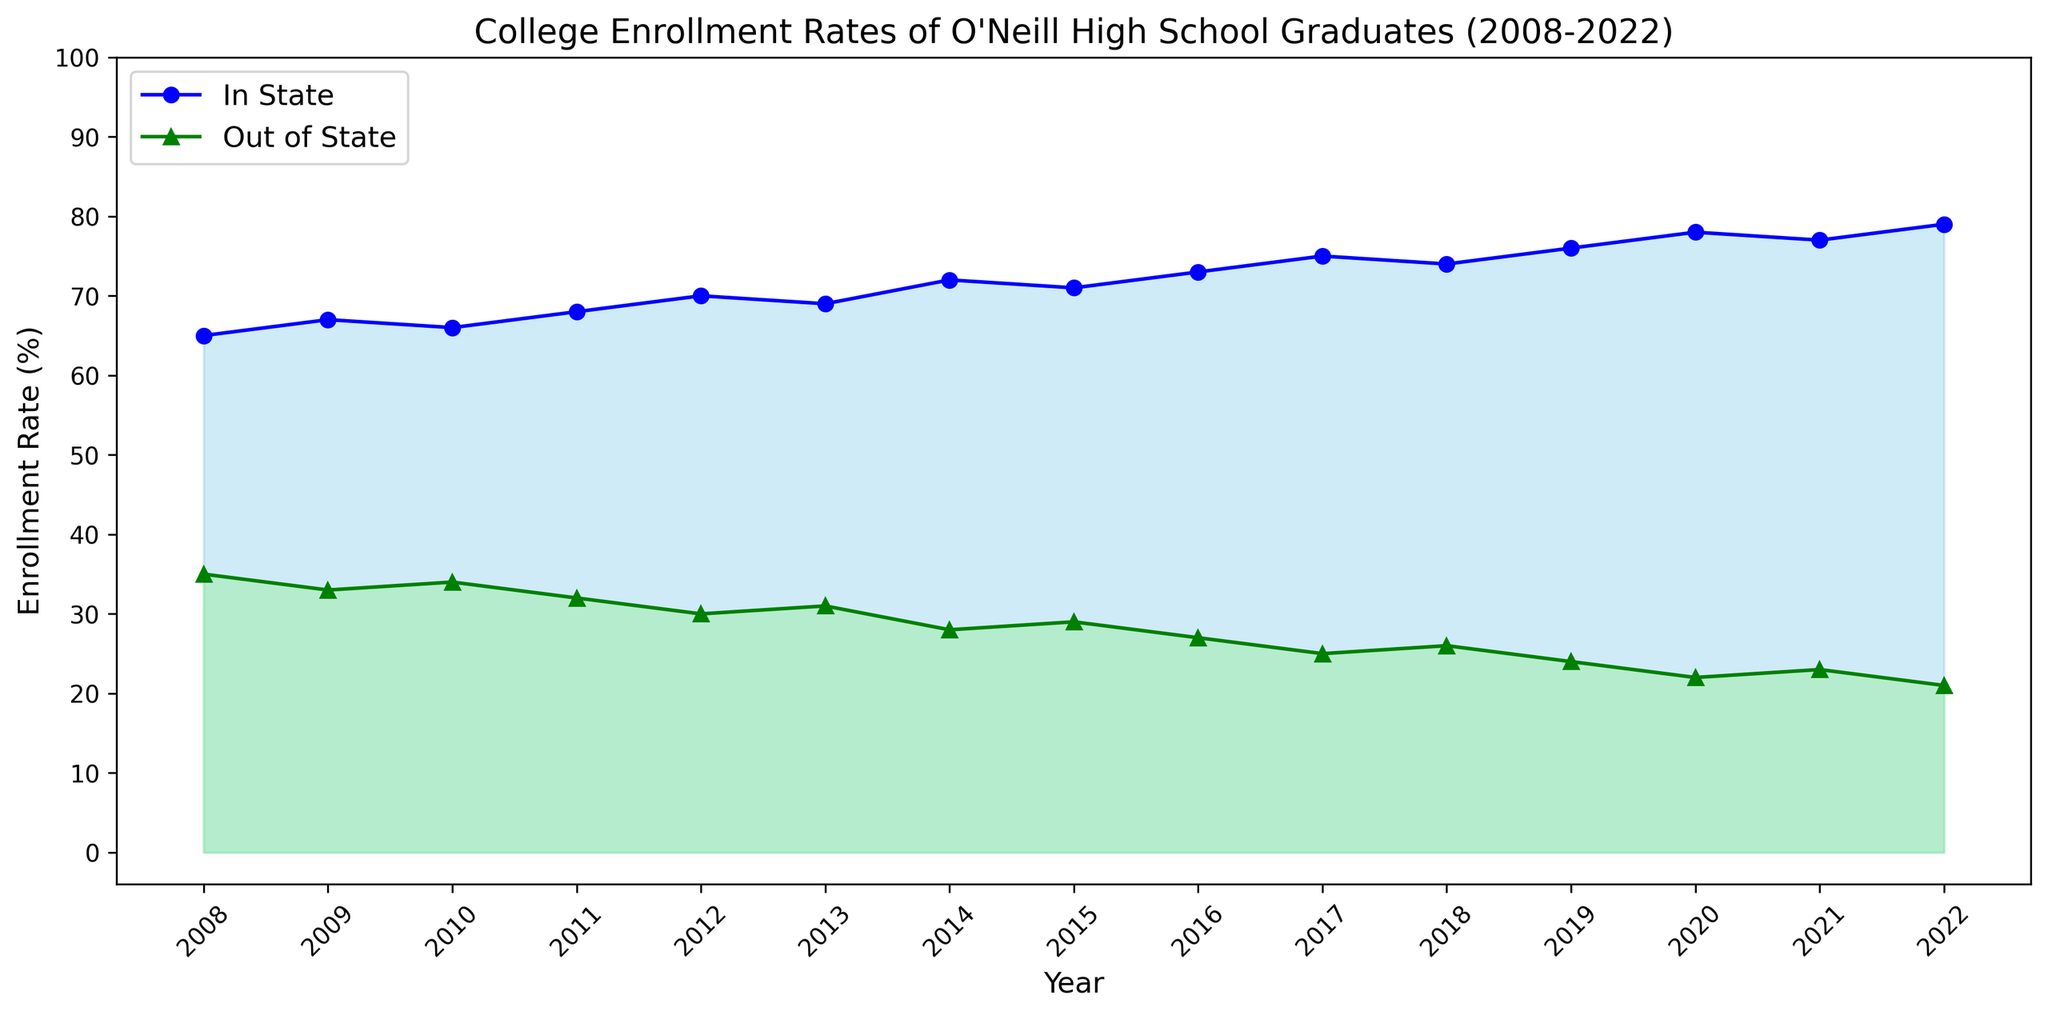What is the enrollment rate for in-state institutions in 2015? Look at the line for in-state enrollment rates on the year 2015. The value is 71%.
Answer: 71% What was the trend in out-of-state enrollment rates from 2017 to 2021? Observe the line chart for out-of-state rates between 2017 and 2021. In 2017, it was 25%, and it declined each year until 2021, where it is 23%.
Answer: Declining Which year had the highest in-state enrollment rate? Observe the in-state line and identify the highest point. The peak is in 2022 with 79%.
Answer: 2022 Comparing in-state and out-of-state enrollment rates, which one had a more significant change from 2008 to 2022? Look at the start and end points for both in-state (65% in 2008 to 79% in 2022) and out-of-state (35% in 2008 to 21% in 2022). In-state changed by 14%, and out-of-state changed by 14%.
Answer: Both had the same change In which year did the in-state enrollment rate first surpass 70%? Look at the line for in-state enrollment rates and find the first occurrence above 70%. It first happens in 2012 with 70%.
Answer: 2012 On average, what was the in-state enrollment rate over the entire period? Sum up all the in-state values: 65 + 67 + 66 + 68 + 70 + 69 + 72 + 71 + 73 + 75 + 74 + 76 + 78 + 77 + 79. Divide by 15 (the number of years) to find the average.
Answer: 71.2% Were there any years when the out-of-state enrollment rate increased compared to the previous year? Observe the year-to-year changes in the out-of-state line. In 2018, the rate increased from 25% to 26%.
Answer: Yes, in 2018 What is the difference in in-state enrollment rates between 2010 and 2020? Look at the in-state rates for 2010 (66%) and 2020 (78%) and calculate the difference: 78 - 66 = 12%.
Answer: 12% Which category showed more stability in enrollment rates over the years? Compare the lines visually to see which has fewer fluctuations. The out-of-state line shows more stability with smaller changes.
Answer: Out-of-state In what year did the combined enrollment rate for in-state and out-of-state institutions equal 100% exactly based on visual observation? Observe the points where in-state and out-of-state sums to 100%. Every year sums to 100%; this is likely an implied constant condition of the data.
Answer: Every year 